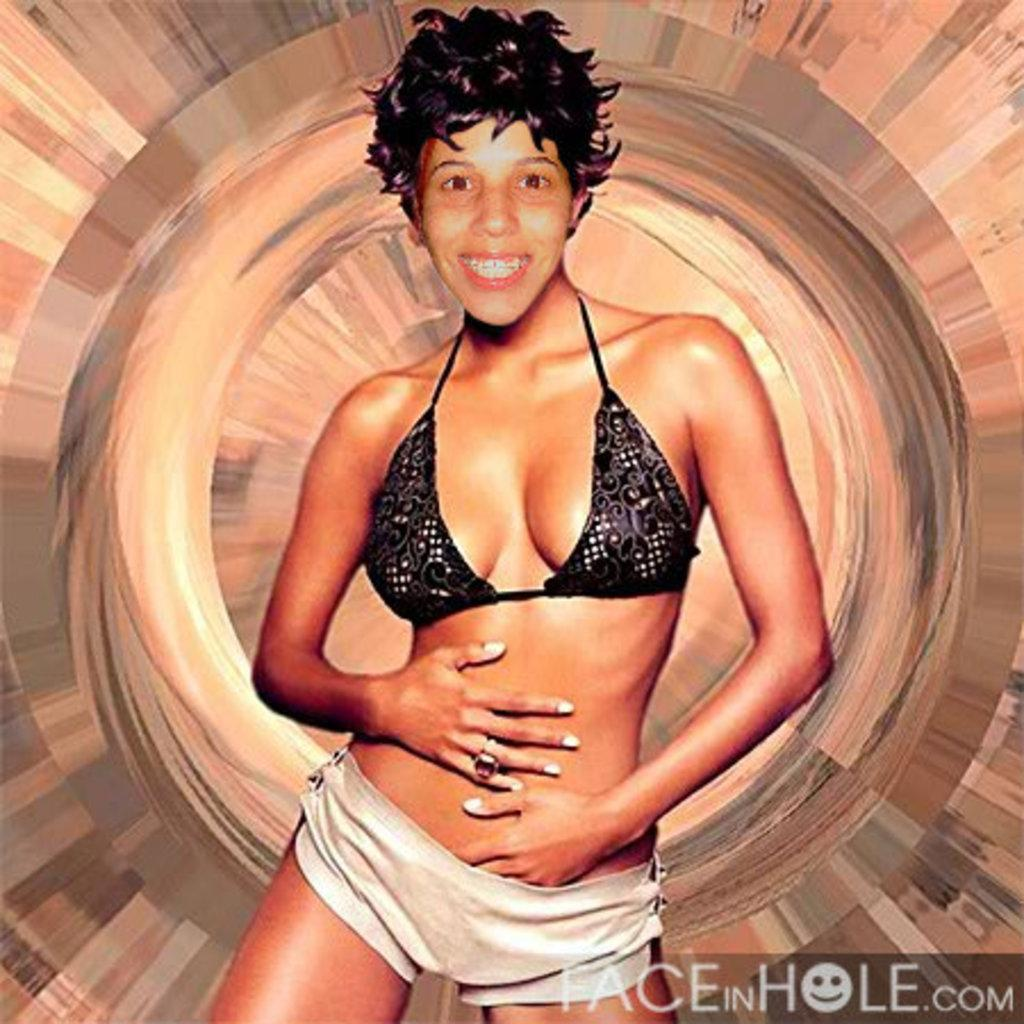What is the main subject of the image? There is a woman standing in the image. Can you describe any additional details about the image? The image is an edited picture. Is there any text present in the image? Yes, there is text in the bottom right corner of the image. How many family members can be seen in the image? There is no information about family members in the image, as it only features a woman standing. What type of thrill can be experienced by the woman in the image? There is no indication of any thrill or excitement in the image, as it simply shows a woman standing. 